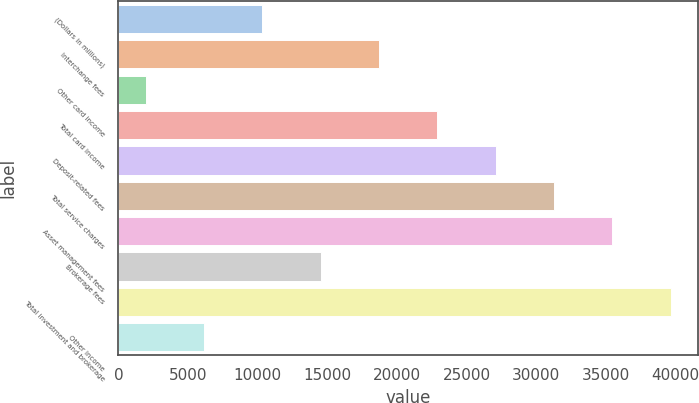Convert chart. <chart><loc_0><loc_0><loc_500><loc_500><bar_chart><fcel>(Dollars in millions)<fcel>Interchange fees<fcel>Other card income<fcel>Total card income<fcel>Deposit-related fees<fcel>Total service charges<fcel>Asset management fees<fcel>Brokerage fees<fcel>Total investment and brokerage<fcel>Other income<nl><fcel>10329.4<fcel>18700.8<fcel>1958<fcel>22886.5<fcel>27072.2<fcel>31257.9<fcel>35443.6<fcel>14515.1<fcel>39629.3<fcel>6143.7<nl></chart> 